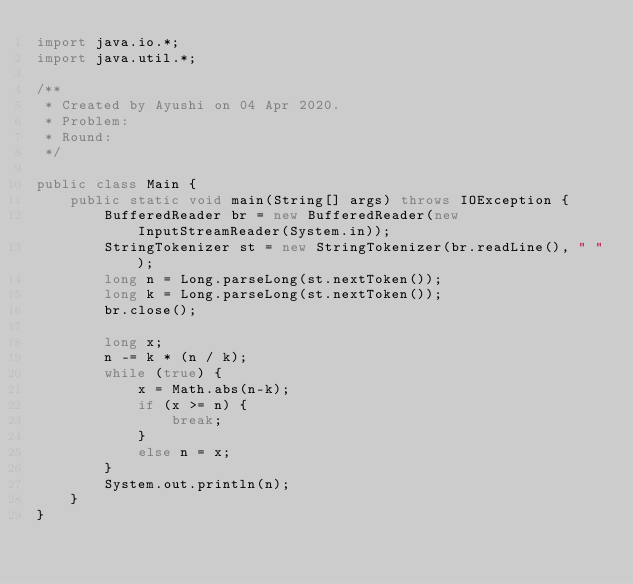<code> <loc_0><loc_0><loc_500><loc_500><_Java_>import java.io.*;
import java.util.*;

/**
 * Created by Ayushi on 04 Apr 2020.
 * Problem:
 * Round:
 */

public class Main {
    public static void main(String[] args) throws IOException {
        BufferedReader br = new BufferedReader(new InputStreamReader(System.in));
        StringTokenizer st = new StringTokenizer(br.readLine(), " ");
        long n = Long.parseLong(st.nextToken());
        long k = Long.parseLong(st.nextToken());
        br.close();

        long x;
        n -= k * (n / k);
        while (true) {
            x = Math.abs(n-k);
            if (x >= n) {
                break;
            }
            else n = x;
        }
        System.out.println(n);
    }
}
</code> 